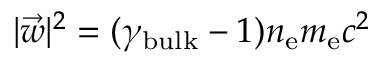<formula> <loc_0><loc_0><loc_500><loc_500>| \vec { w } | ^ { 2 } = ( \gamma _ { b u l k } - 1 ) n _ { e } m _ { e } c ^ { 2 }</formula> 